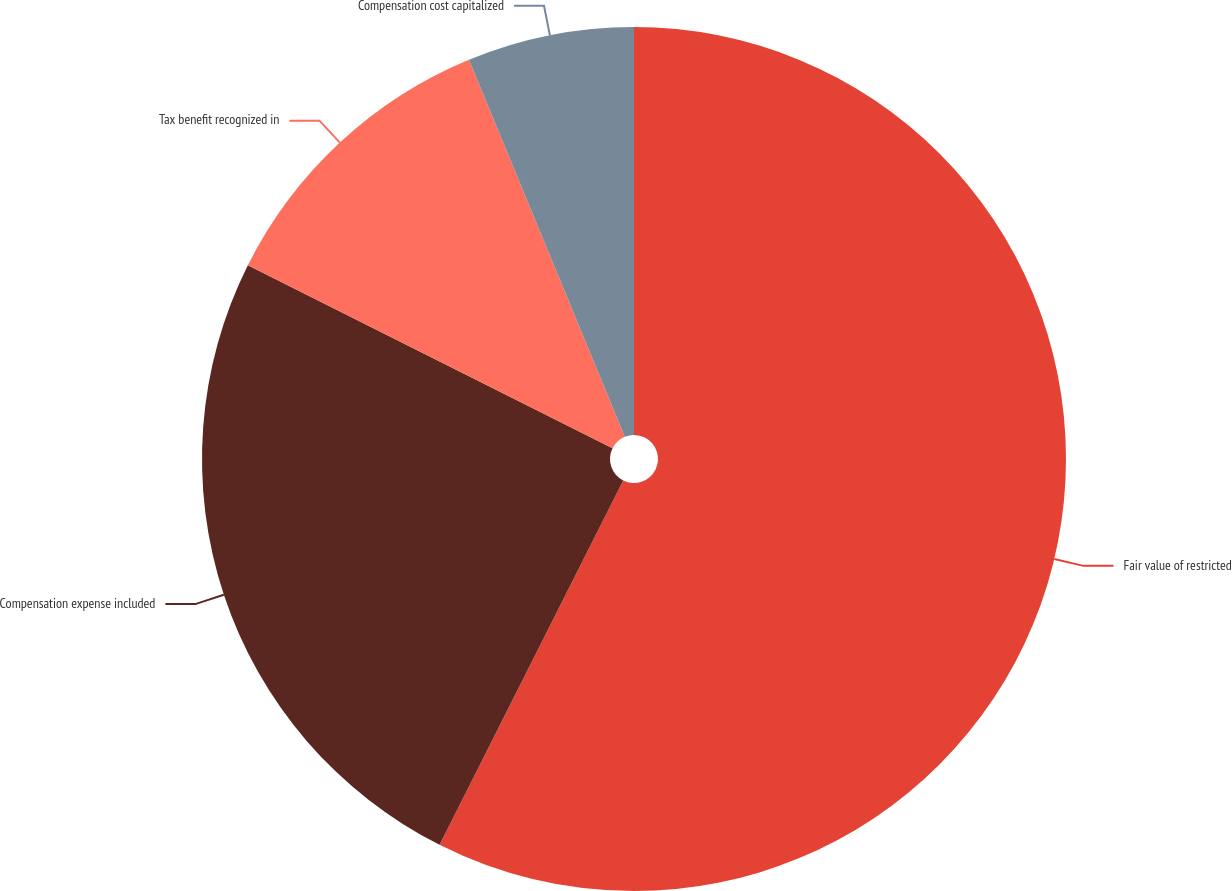Convert chart. <chart><loc_0><loc_0><loc_500><loc_500><pie_chart><fcel>Fair value of restricted<fcel>Compensation expense included<fcel>Tax benefit recognized in<fcel>Compensation cost capitalized<nl><fcel>57.43%<fcel>24.97%<fcel>11.36%<fcel>6.24%<nl></chart> 